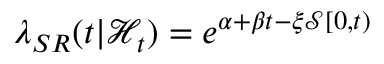Convert formula to latex. <formula><loc_0><loc_0><loc_500><loc_500>\lambda _ { S R } ( t | \mathcal { H } _ { t } ) = e ^ { \alpha + \beta t - \xi \mathcal { S } [ 0 , t ) }</formula> 